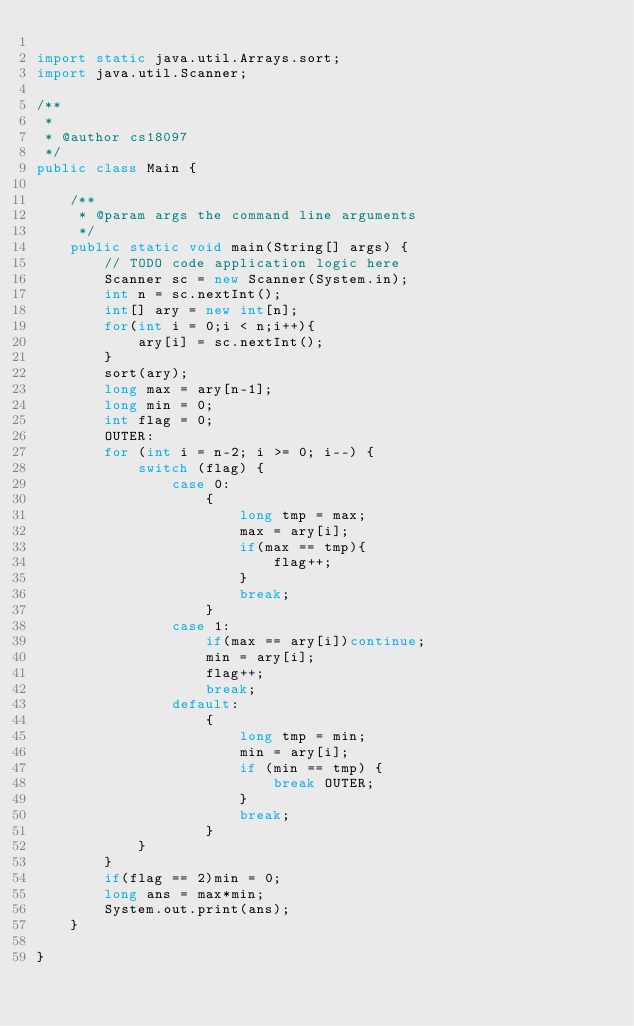Convert code to text. <code><loc_0><loc_0><loc_500><loc_500><_Java_>
import static java.util.Arrays.sort;
import java.util.Scanner;

/**
 *
 * @author cs18097
 */
public class Main {

    /**
     * @param args the command line arguments
     */
    public static void main(String[] args) {
        // TODO code application logic here
        Scanner sc = new Scanner(System.in);
        int n = sc.nextInt();
        int[] ary = new int[n];
        for(int i = 0;i < n;i++){
            ary[i] = sc.nextInt();
        }
        sort(ary);
        long max = ary[n-1];
        long min = 0;
        int flag = 0;
        OUTER:
        for (int i = n-2; i >= 0; i--) {
            switch (flag) {
                case 0:
                    {
                        long tmp = max;
                        max = ary[i];
                        if(max == tmp){
                            flag++;
                        }       
                        break;
                    }
                case 1:
                    if(max == ary[i])continue;
                    min = ary[i];
                    flag++;
                    break;
                default:
                    {
                        long tmp = min;
                        min = ary[i];
                        if (min == tmp) {
                            break OUTER;
                        }
                        break;
                    }
            }
        }
        if(flag == 2)min = 0;
        long ans = max*min;
        System.out.print(ans);
    }
    
}
</code> 